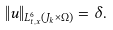<formula> <loc_0><loc_0><loc_500><loc_500>\| u \| _ { L _ { t , x } ^ { 6 } ( J _ { k } \times \Omega ) } = \delta .</formula> 